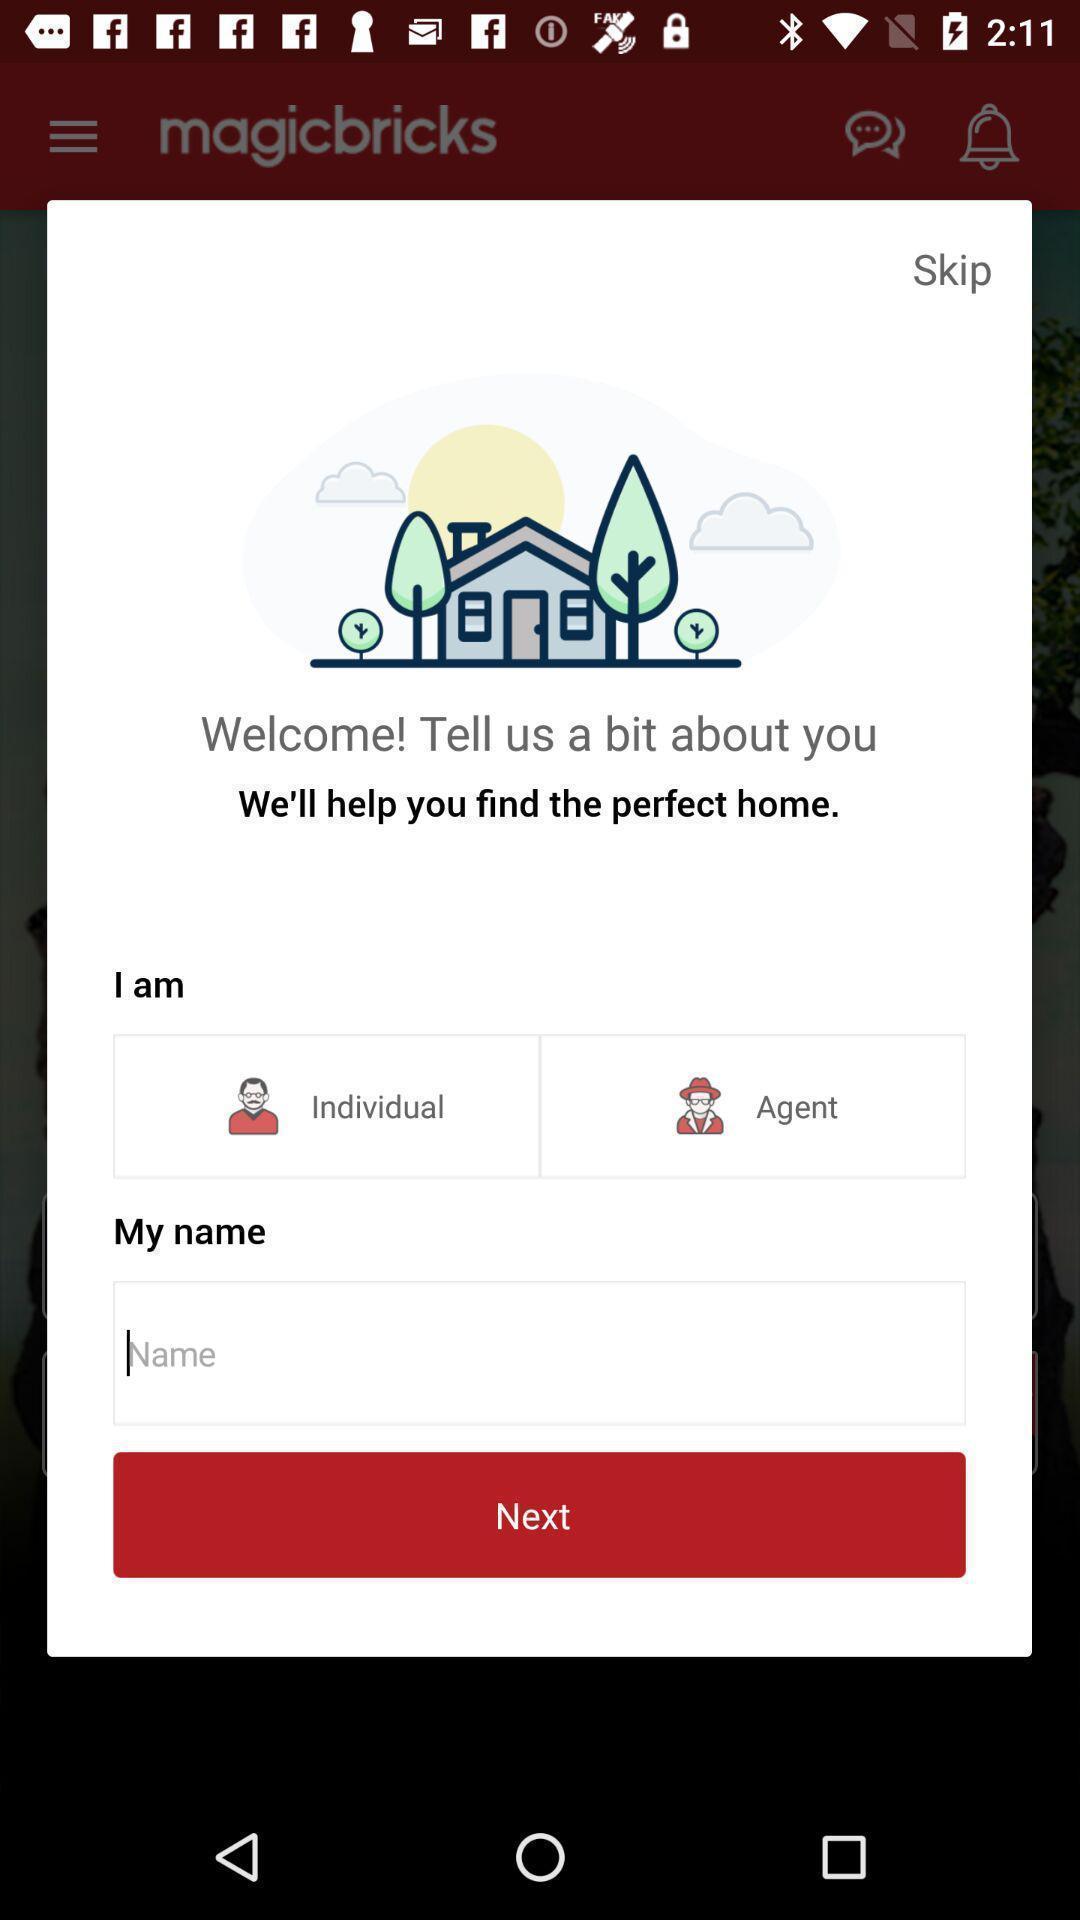What can you discern from this picture? Pop-up to enter personal information. 